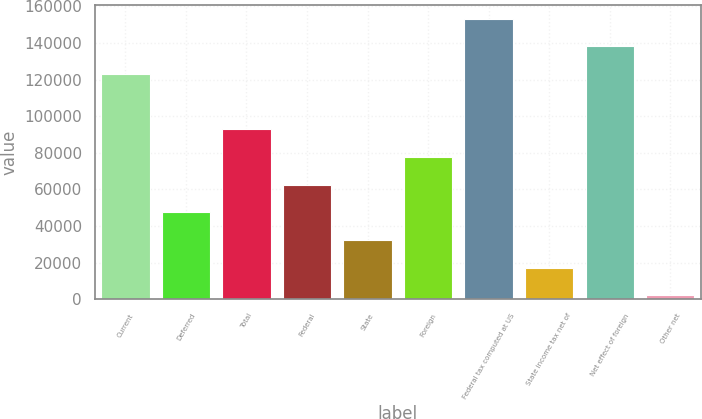<chart> <loc_0><loc_0><loc_500><loc_500><bar_chart><fcel>Current<fcel>Deferred<fcel>Total<fcel>Federal<fcel>State<fcel>Foreign<fcel>Federal tax computed at US<fcel>State income tax net of<fcel>Net effect of foreign<fcel>Other net<nl><fcel>123023<fcel>47451.9<fcel>92794.8<fcel>62566.2<fcel>32337.6<fcel>77680.5<fcel>153252<fcel>17223.3<fcel>138138<fcel>2109<nl></chart> 